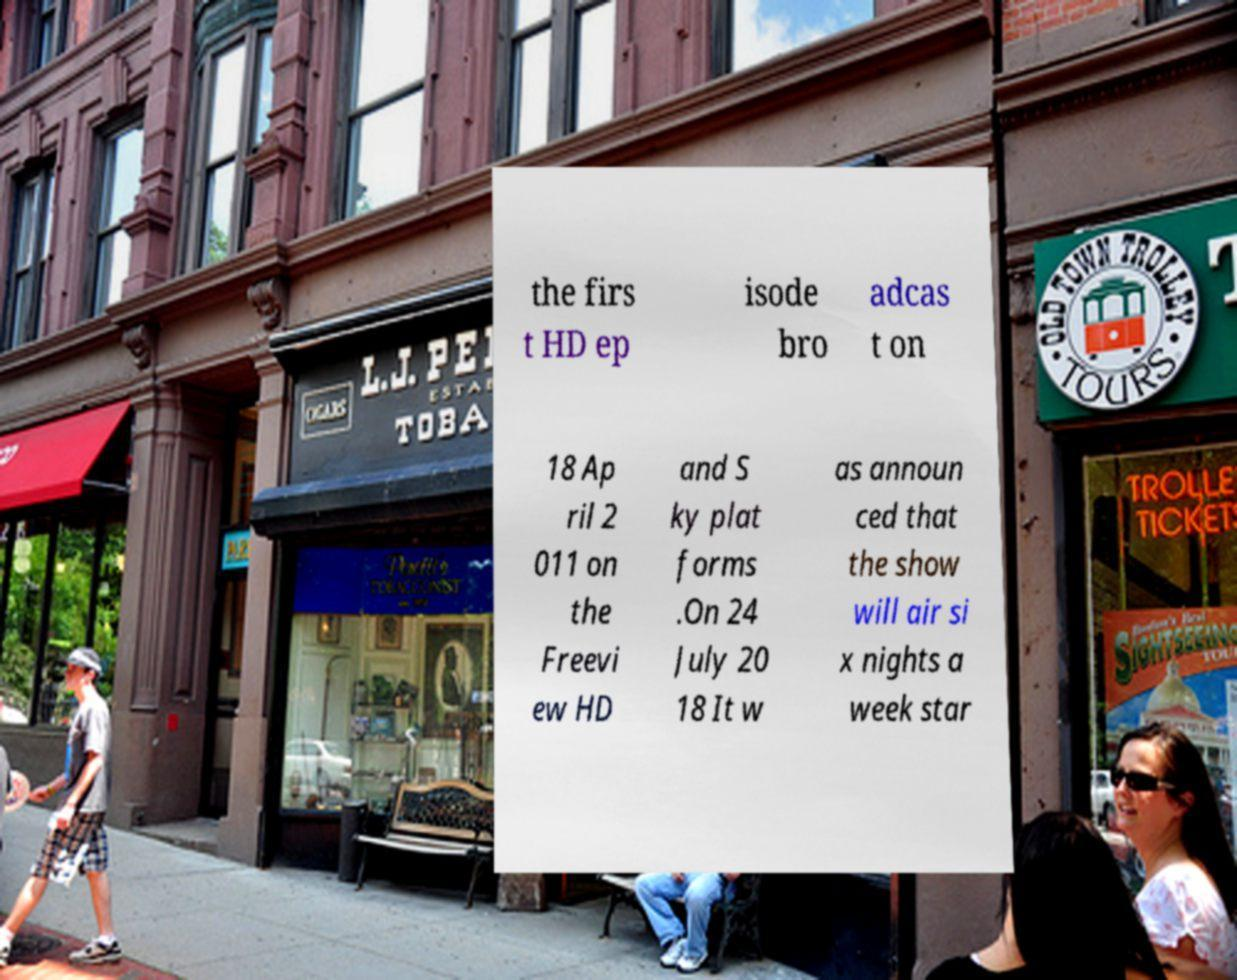Can you accurately transcribe the text from the provided image for me? the firs t HD ep isode bro adcas t on 18 Ap ril 2 011 on the Freevi ew HD and S ky plat forms .On 24 July 20 18 It w as announ ced that the show will air si x nights a week star 